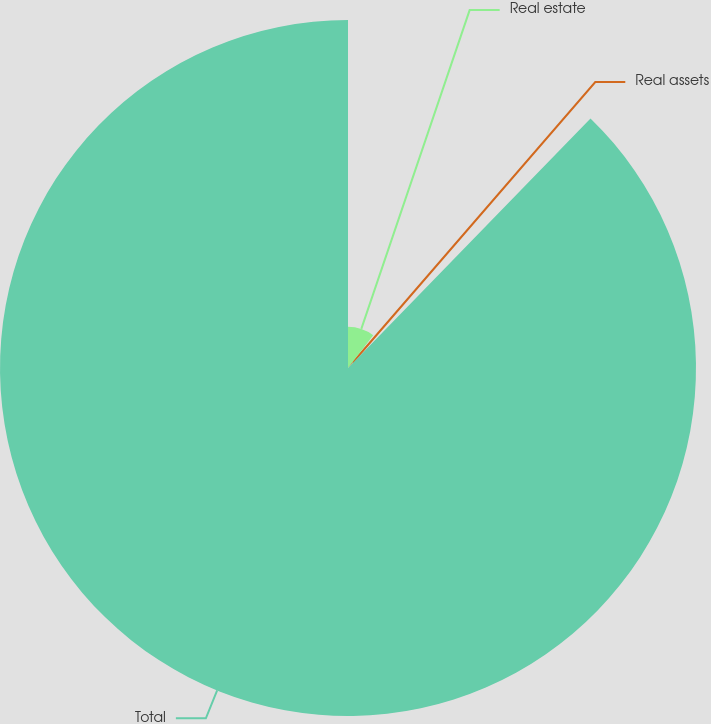<chart> <loc_0><loc_0><loc_500><loc_500><pie_chart><fcel>Real estate<fcel>Real assets<fcel>Total<nl><fcel>10.43%<fcel>1.84%<fcel>87.73%<nl></chart> 